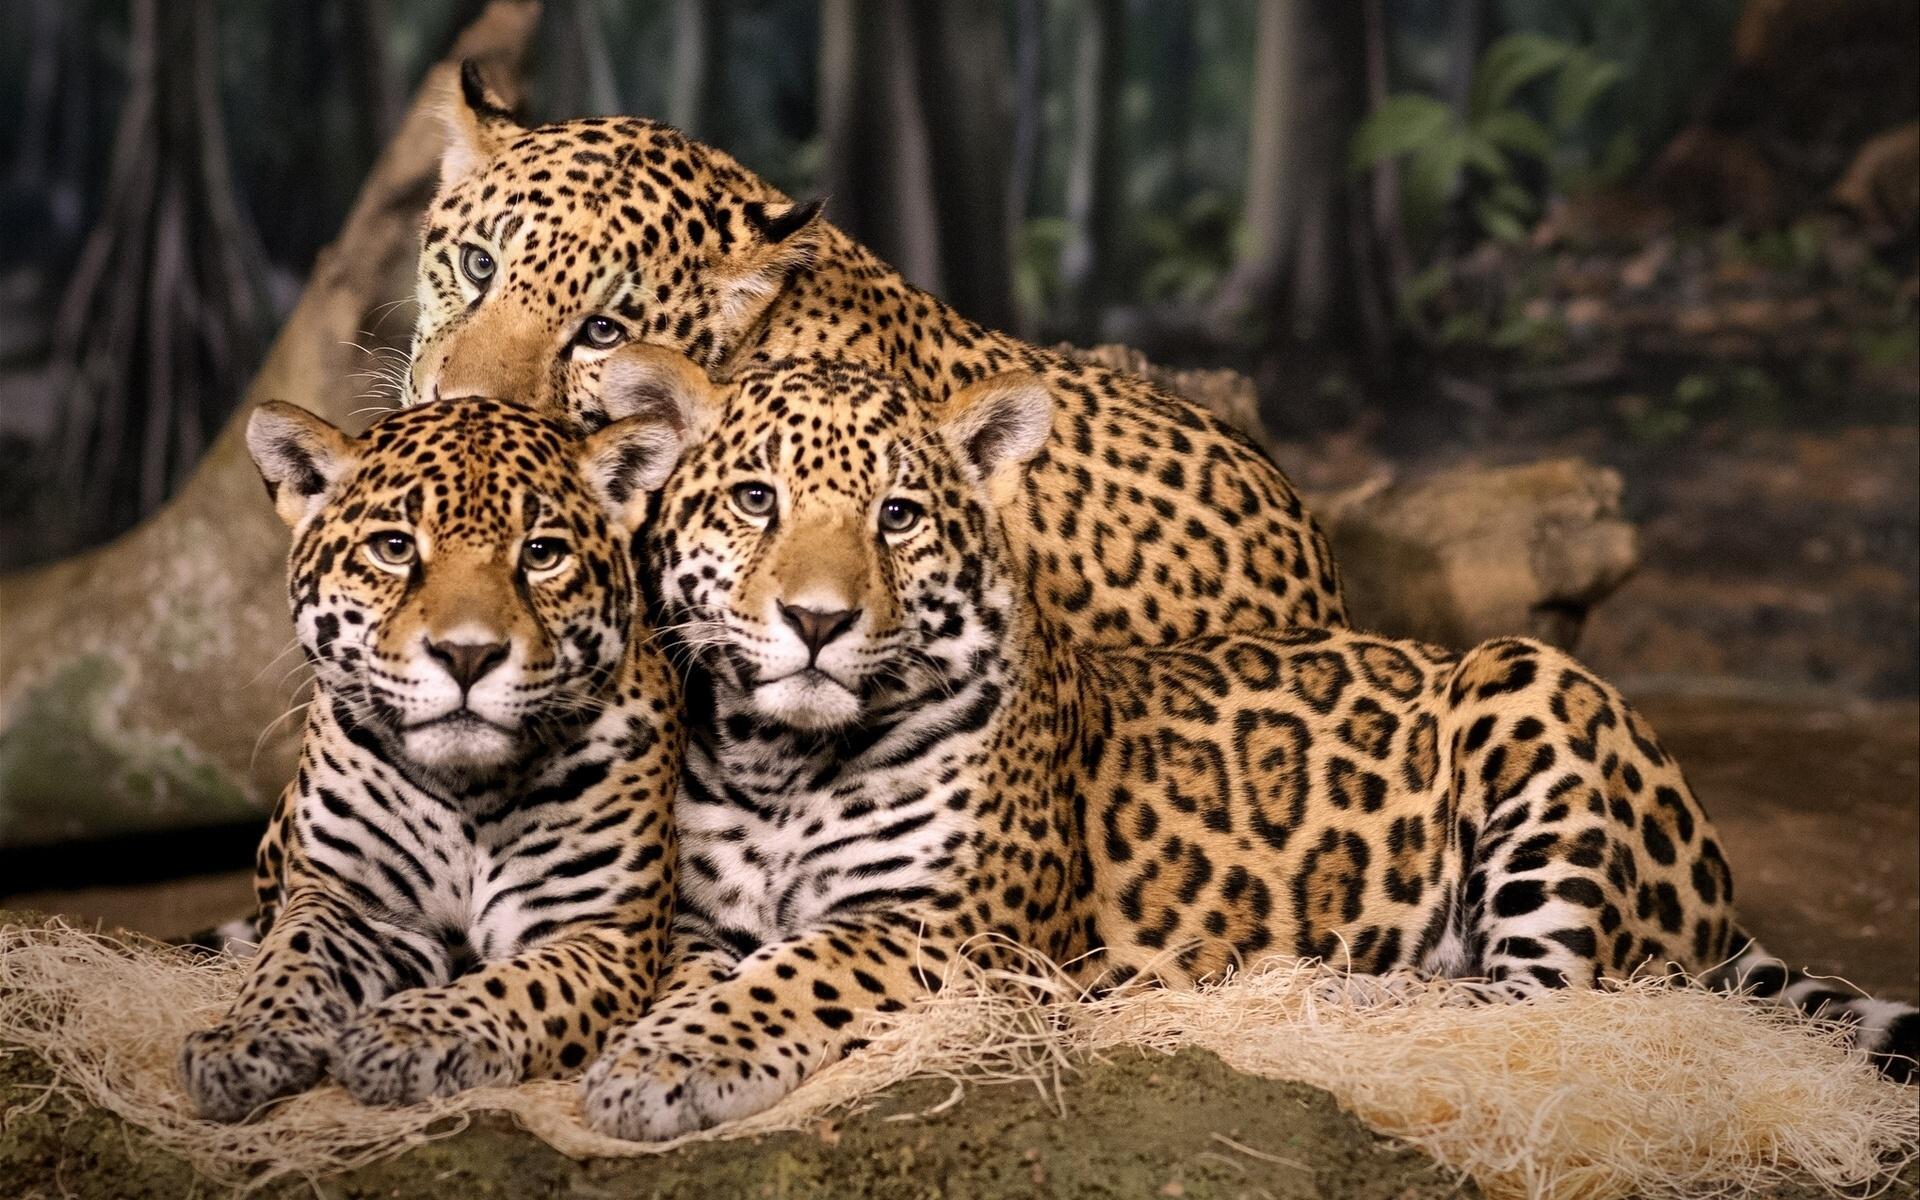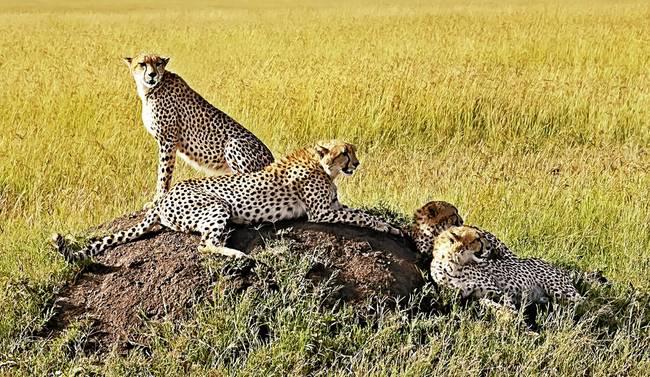The first image is the image on the left, the second image is the image on the right. Considering the images on both sides, is "Four leopards are laying on a dirt patch in a yellow-green field in one of the images." valid? Answer yes or no. Yes. 